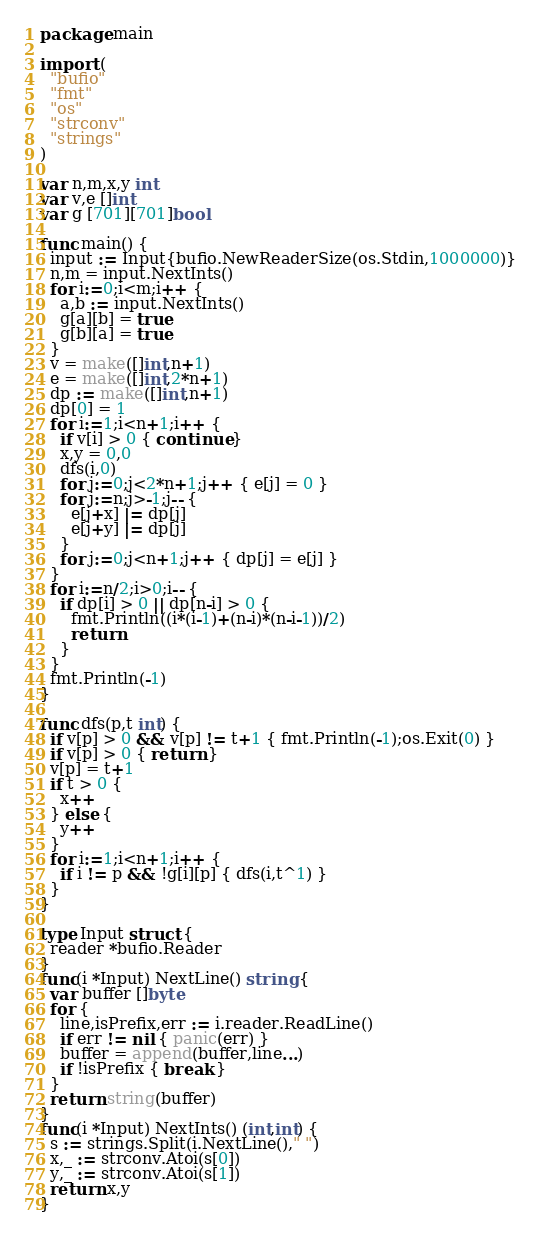<code> <loc_0><loc_0><loc_500><loc_500><_Go_>package main

import (
  "bufio"
  "fmt"
  "os"
  "strconv"
  "strings"
)

var n,m,x,y int
var v,e []int
var g [701][701]bool

func main() {
  input := Input{bufio.NewReaderSize(os.Stdin,1000000)}
  n,m = input.NextInts()
  for i:=0;i<m;i++ {
    a,b := input.NextInts()
    g[a][b] = true
    g[b][a] = true
  }
  v = make([]int,n+1)
  e = make([]int,2*n+1)
  dp := make([]int,n+1)
  dp[0] = 1
  for i:=1;i<n+1;i++ {
    if v[i] > 0 { continue }
    x,y = 0,0
    dfs(i,0)
    for j:=0;j<2*n+1;j++ { e[j] = 0 }
    for j:=n;j>-1;j-- {
      e[j+x] |= dp[j]
      e[j+y] |= dp[j]
    }
    for j:=0;j<n+1;j++ { dp[j] = e[j] }
  }
  for i:=n/2;i>0;i-- {
    if dp[i] > 0 || dp[n-i] > 0 {
      fmt.Println((i*(i-1)+(n-i)*(n-i-1))/2)
      return
    }
  }
  fmt.Println(-1)
}

func dfs(p,t int) {
  if v[p] > 0 && v[p] != t+1 { fmt.Println(-1);os.Exit(0) }
  if v[p] > 0 { return }
  v[p] = t+1
  if t > 0 {
    x++
  } else {
    y++
  }
  for i:=1;i<n+1;i++ {
    if i != p && !g[i][p] { dfs(i,t^1) }
  }
}

type Input struct {
  reader *bufio.Reader
}
func(i *Input) NextLine() string {
  var buffer []byte
  for {
    line,isPrefix,err := i.reader.ReadLine()
    if err != nil { panic(err) }
    buffer = append(buffer,line...)
    if !isPrefix { break }
  }
  return string(buffer)
}
func(i *Input) NextInts() (int,int) {
  s := strings.Split(i.NextLine()," ")
  x,_ := strconv.Atoi(s[0])
  y,_ := strconv.Atoi(s[1])
  return x,y
}</code> 